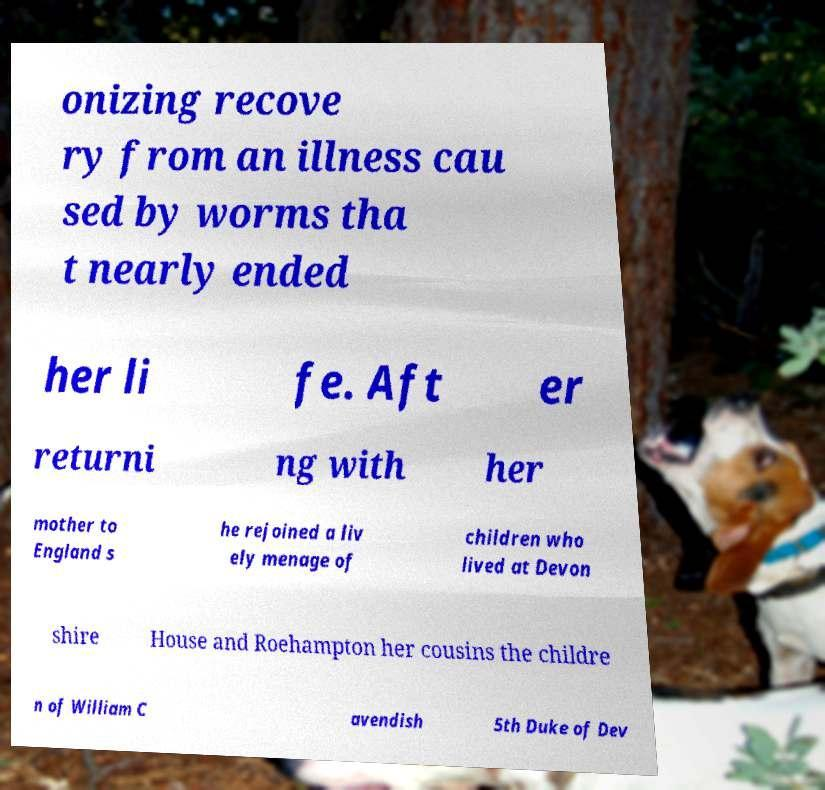Please identify and transcribe the text found in this image. onizing recove ry from an illness cau sed by worms tha t nearly ended her li fe. Aft er returni ng with her mother to England s he rejoined a liv ely menage of children who lived at Devon shire House and Roehampton her cousins the childre n of William C avendish 5th Duke of Dev 